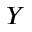<formula> <loc_0><loc_0><loc_500><loc_500>Y</formula> 